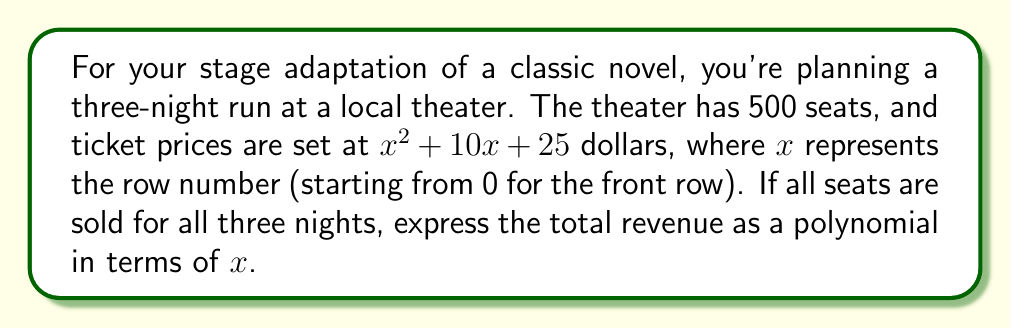Could you help me with this problem? Let's approach this step-by-step:

1) First, we need to find the revenue for one seat in row $x$:
   Revenue per seat = $x^2 + 10x + 25$ dollars

2) Now, we need to sum this for all 500 seats. The theater has multiple rows, so we can't simply multiply by 500. Instead, we need to find the sum of this polynomial for all rows.

3) In a 500-seat theater, let's assume there are 20 seats per row. This means there are 25 rows (500 ÷ 20 = 25).

4) The sum of a polynomial over a range of values can be represented using sigma notation:

   $$\sum_{x=0}^{24} 20(x^2 + 10x + 25)$$

5) We can distribute the 20:

   $$\sum_{x=0}^{24} (20x^2 + 200x + 500)$$

6) Now, we can use the formulas for the sum of arithmetic sequences:
   $$\sum_{x=0}^n x = \frac{n(n+1)}{2}$$
   $$\sum_{x=0}^n x^2 = \frac{n(n+1)(2n+1)}{6}$$

7) Applying these (with n = 24):
   $$20 \cdot \frac{24 \cdot 25 \cdot 49}{6} + 200 \cdot \frac{24 \cdot 25}{2} + 500 \cdot 25$$

8) This simplifies to:
   $$49000 + 60000 + 12500 = 121500$$

9) This is the revenue for one night. For three nights, we multiply by 3:

   $$3 \cdot 121500 = 364500$$

Therefore, the total revenue for all three nights is $364,500.
Answer: $364,500 